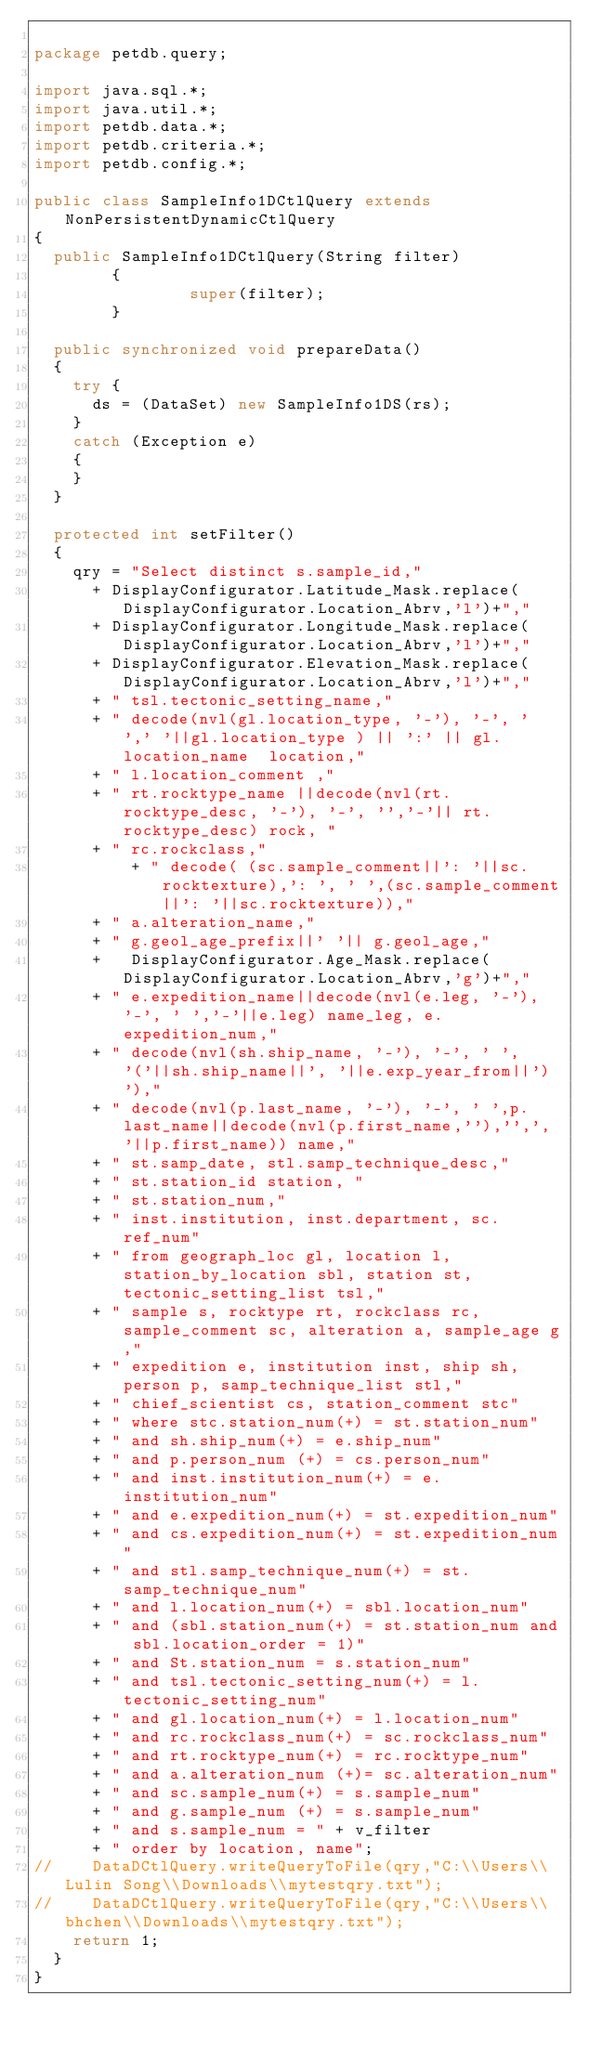<code> <loc_0><loc_0><loc_500><loc_500><_Java_>
package petdb.query;

import java.sql.*;
import java.util.*;
import petdb.data.*;
import petdb.criteria.*;
import petdb.config.*;

public class SampleInfo1DCtlQuery extends NonPersistentDynamicCtlQuery 
{
	public SampleInfo1DCtlQuery(String filter)
        {
                super(filter);
        }

	public synchronized void prepareData() 
	{
		try {
			ds = (DataSet) new SampleInfo1DS(rs);
		} 
		catch (Exception e) 
		{
		}
	}

	protected int setFilter()
	{
		qry = "Select distinct s.sample_id,"
			+ DisplayConfigurator.Latitude_Mask.replace(DisplayConfigurator.Location_Abrv,'l')+","
			+ DisplayConfigurator.Longitude_Mask.replace(DisplayConfigurator.Location_Abrv,'l')+","
			+ DisplayConfigurator.Elevation_Mask.replace(DisplayConfigurator.Location_Abrv,'l')+","
			+ " tsl.tectonic_setting_name,"
			+ " decode(nvl(gl.location_type, '-'), '-', ' ',' '||gl.location_type ) || ':' || gl.location_name  location,"
			+ " l.location_comment ,"
			+ " rt.rocktype_name ||decode(nvl(rt.rocktype_desc, '-'), '-', '','-'|| rt.rocktype_desc) rock, "
			+ " rc.rockclass,"
		    	+ " decode( (sc.sample_comment||': '||sc.rocktexture),': ', ' ',(sc.sample_comment||': '||sc.rocktexture)),"
			+ " a.alteration_name,"
			+ " g.geol_age_prefix||' '|| g.geol_age,"
			+   DisplayConfigurator.Age_Mask.replace(DisplayConfigurator.Location_Abrv,'g')+","
			+ " e.expedition_name||decode(nvl(e.leg, '-'), '-', ' ','-'||e.leg) name_leg, e.expedition_num,"
			+ " decode(nvl(sh.ship_name, '-'), '-', ' ', '('||sh.ship_name||', '||e.exp_year_from||')'),"
			+ " decode(nvl(p.last_name, '-'), '-', ' ',p.last_name||decode(nvl(p.first_name,''),'',', '||p.first_name)) name,"
			+ " st.samp_date, stl.samp_technique_desc,"
			+ " st.station_id station, "
			+ " st.station_num,"
			+ " inst.institution, inst.department, sc.ref_num"
			+ " from geograph_loc gl, location l, station_by_location sbl, station st, tectonic_setting_list tsl,"
			+ " sample s, rocktype rt, rockclass rc, sample_comment sc, alteration a, sample_age g,"
			+ " expedition e, institution inst, ship sh, person p, samp_technique_list stl,"
			+ " chief_scientist cs, station_comment stc"
			+ " where stc.station_num(+) = st.station_num"
			+ " and sh.ship_num(+) = e.ship_num"
			+ " and p.person_num (+) = cs.person_num"
			+ " and inst.institution_num(+) = e.institution_num"
			+ " and e.expedition_num(+) = st.expedition_num"
			+ " and cs.expedition_num(+) = st.expedition_num"
			+ " and stl.samp_technique_num(+) = st.samp_technique_num"
			+ " and l.location_num(+) = sbl.location_num"
			+ " and (sbl.station_num(+) = st.station_num and sbl.location_order = 1)"
			+ " and St.station_num = s.station_num"
			+ " and tsl.tectonic_setting_num(+) = l.tectonic_setting_num"
			+ " and gl.location_num(+) = l.location_num"
			+ " and rc.rockclass_num(+) = sc.rockclass_num"
			+ " and rt.rocktype_num(+) = rc.rocktype_num"
			+ " and a.alteration_num (+)= sc.alteration_num"
			+ " and sc.sample_num(+) = s.sample_num"
			+ " and g.sample_num (+) = s.sample_num"
			+ " and s.sample_num = " + v_filter 
			+ " order by location, name";    
//		DataDCtlQuery.writeQueryToFile(qry,"C:\\Users\\Lulin Song\\Downloads\\mytestqry.txt");
//		DataDCtlQuery.writeQueryToFile(qry,"C:\\Users\\bhchen\\Downloads\\mytestqry.txt");
		return 1;
	} 	  
}

</code> 